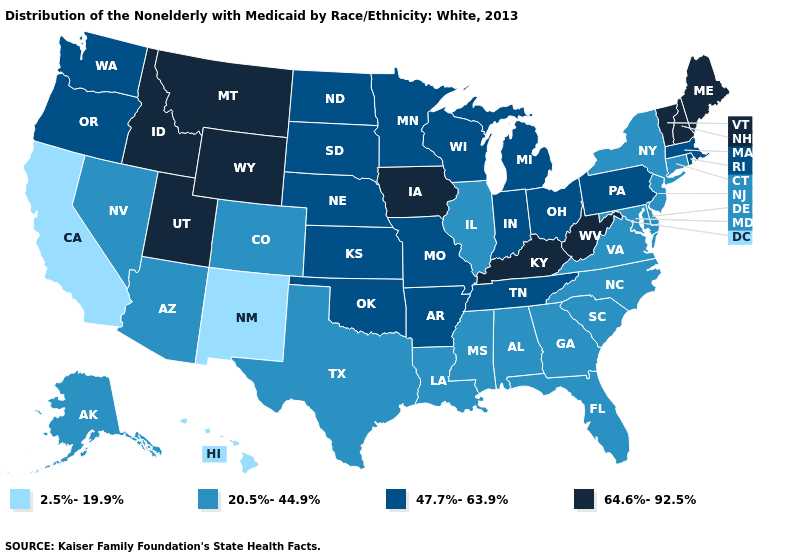What is the lowest value in states that border Washington?
Concise answer only. 47.7%-63.9%. Among the states that border California , does Arizona have the highest value?
Keep it brief. No. What is the lowest value in the West?
Keep it brief. 2.5%-19.9%. Does Maine have the highest value in the Northeast?
Answer briefly. Yes. What is the value of New Jersey?
Short answer required. 20.5%-44.9%. What is the value of Hawaii?
Short answer required. 2.5%-19.9%. Does the map have missing data?
Short answer required. No. Which states have the highest value in the USA?
Short answer required. Idaho, Iowa, Kentucky, Maine, Montana, New Hampshire, Utah, Vermont, West Virginia, Wyoming. What is the value of Arizona?
Give a very brief answer. 20.5%-44.9%. What is the value of Alabama?
Give a very brief answer. 20.5%-44.9%. Does Kentucky have the highest value in the USA?
Concise answer only. Yes. Does Pennsylvania have the highest value in the Northeast?
Short answer required. No. Does Nevada have a higher value than Washington?
Short answer required. No. Among the states that border Mississippi , does Alabama have the lowest value?
Give a very brief answer. Yes. What is the highest value in states that border New Mexico?
Quick response, please. 64.6%-92.5%. 